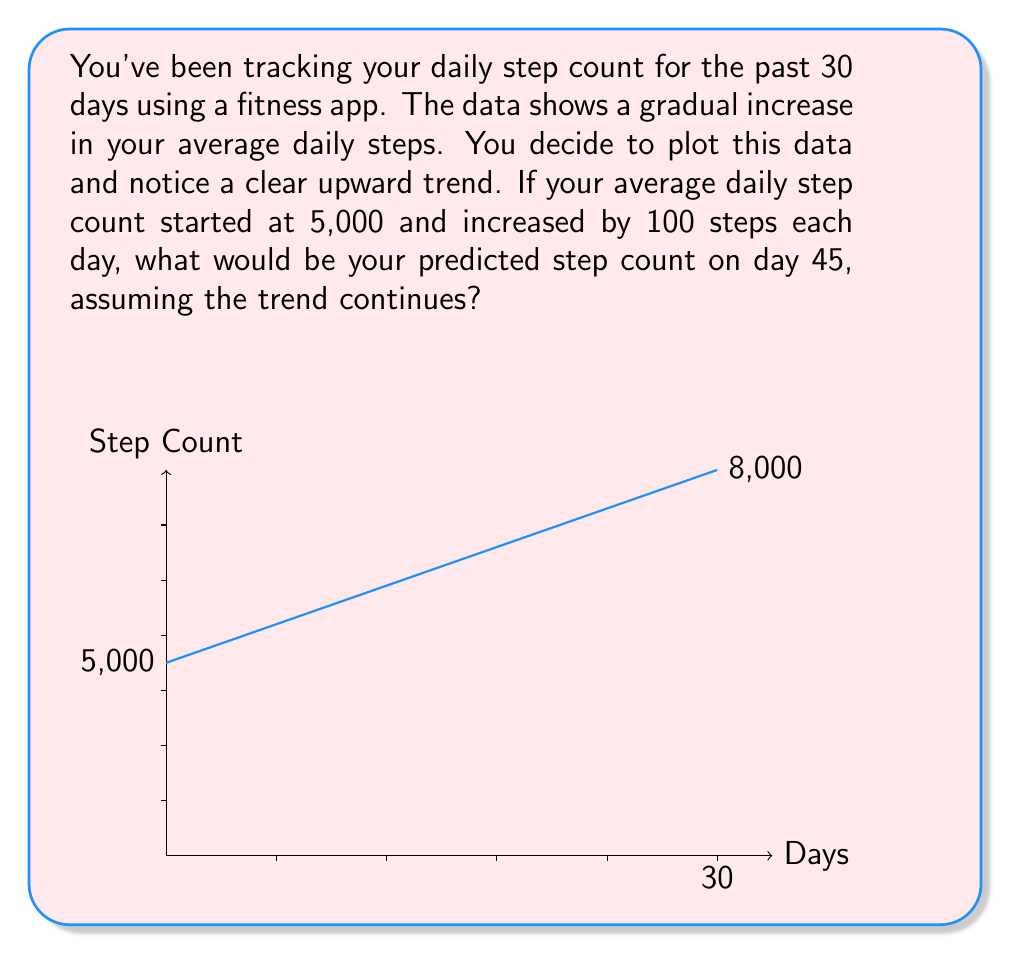What is the answer to this math problem? To solve this problem, we need to identify the trend in the time series data and use it to make a prediction. Let's break it down step-by-step:

1. Identify the trend:
   - The initial step count is 5,000
   - The daily increase is 100 steps

2. Express the trend as a linear equation:
   Let $y$ be the step count and $x$ be the number of days.
   $$y = 5000 + 100x$$

3. Calculate the predicted step count for day 45:
   - Substitute $x = 45$ into the equation:
     $$y = 5000 + 100(45)$$
   
4. Solve the equation:
   $$y = 5000 + 4500 = 9500$$

Therefore, if the trend continues, the predicted step count on day 45 would be 9,500 steps.
Answer: 9,500 steps 